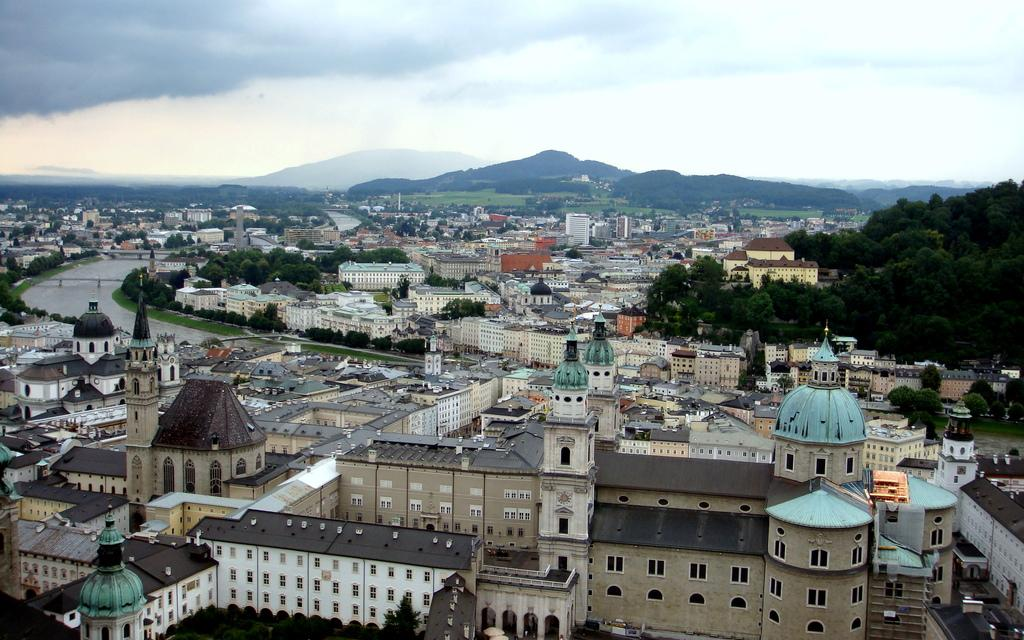What is the main structure in the center of the image? There is a bridge in the center of the image. What natural element is visible in the image? There is water visible in the image. What type of man-made structures can be seen in the image? There are buildings in the image. What type of vegetation is present in the image? There are trees in the image. What can be seen in the distance in the background of the image? There are mountains visible in the background of the image. What is visible above the mountains in the background? The sky is visible in the background of the image. What type of stone is the bee carrying in the image? There is no bee or stone present in the image. Can you see an airplane flying over the mountains in the image? There is no airplane visible in the image. 